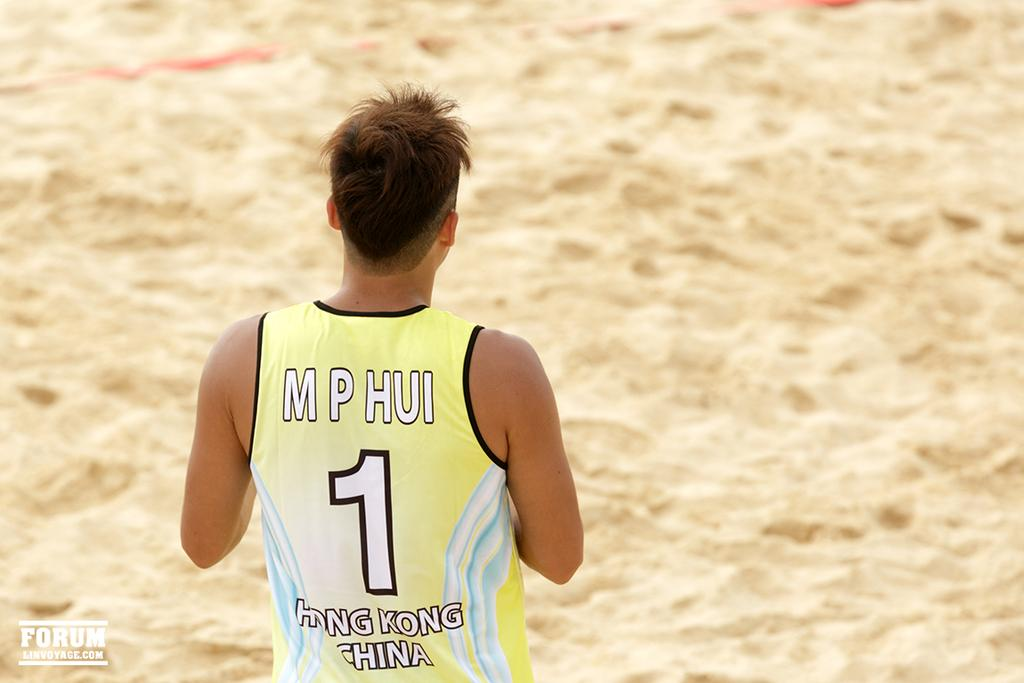Provide a one-sentence caption for the provided image. Guy with a yellow jersey for hong kong china is standing on sand. 